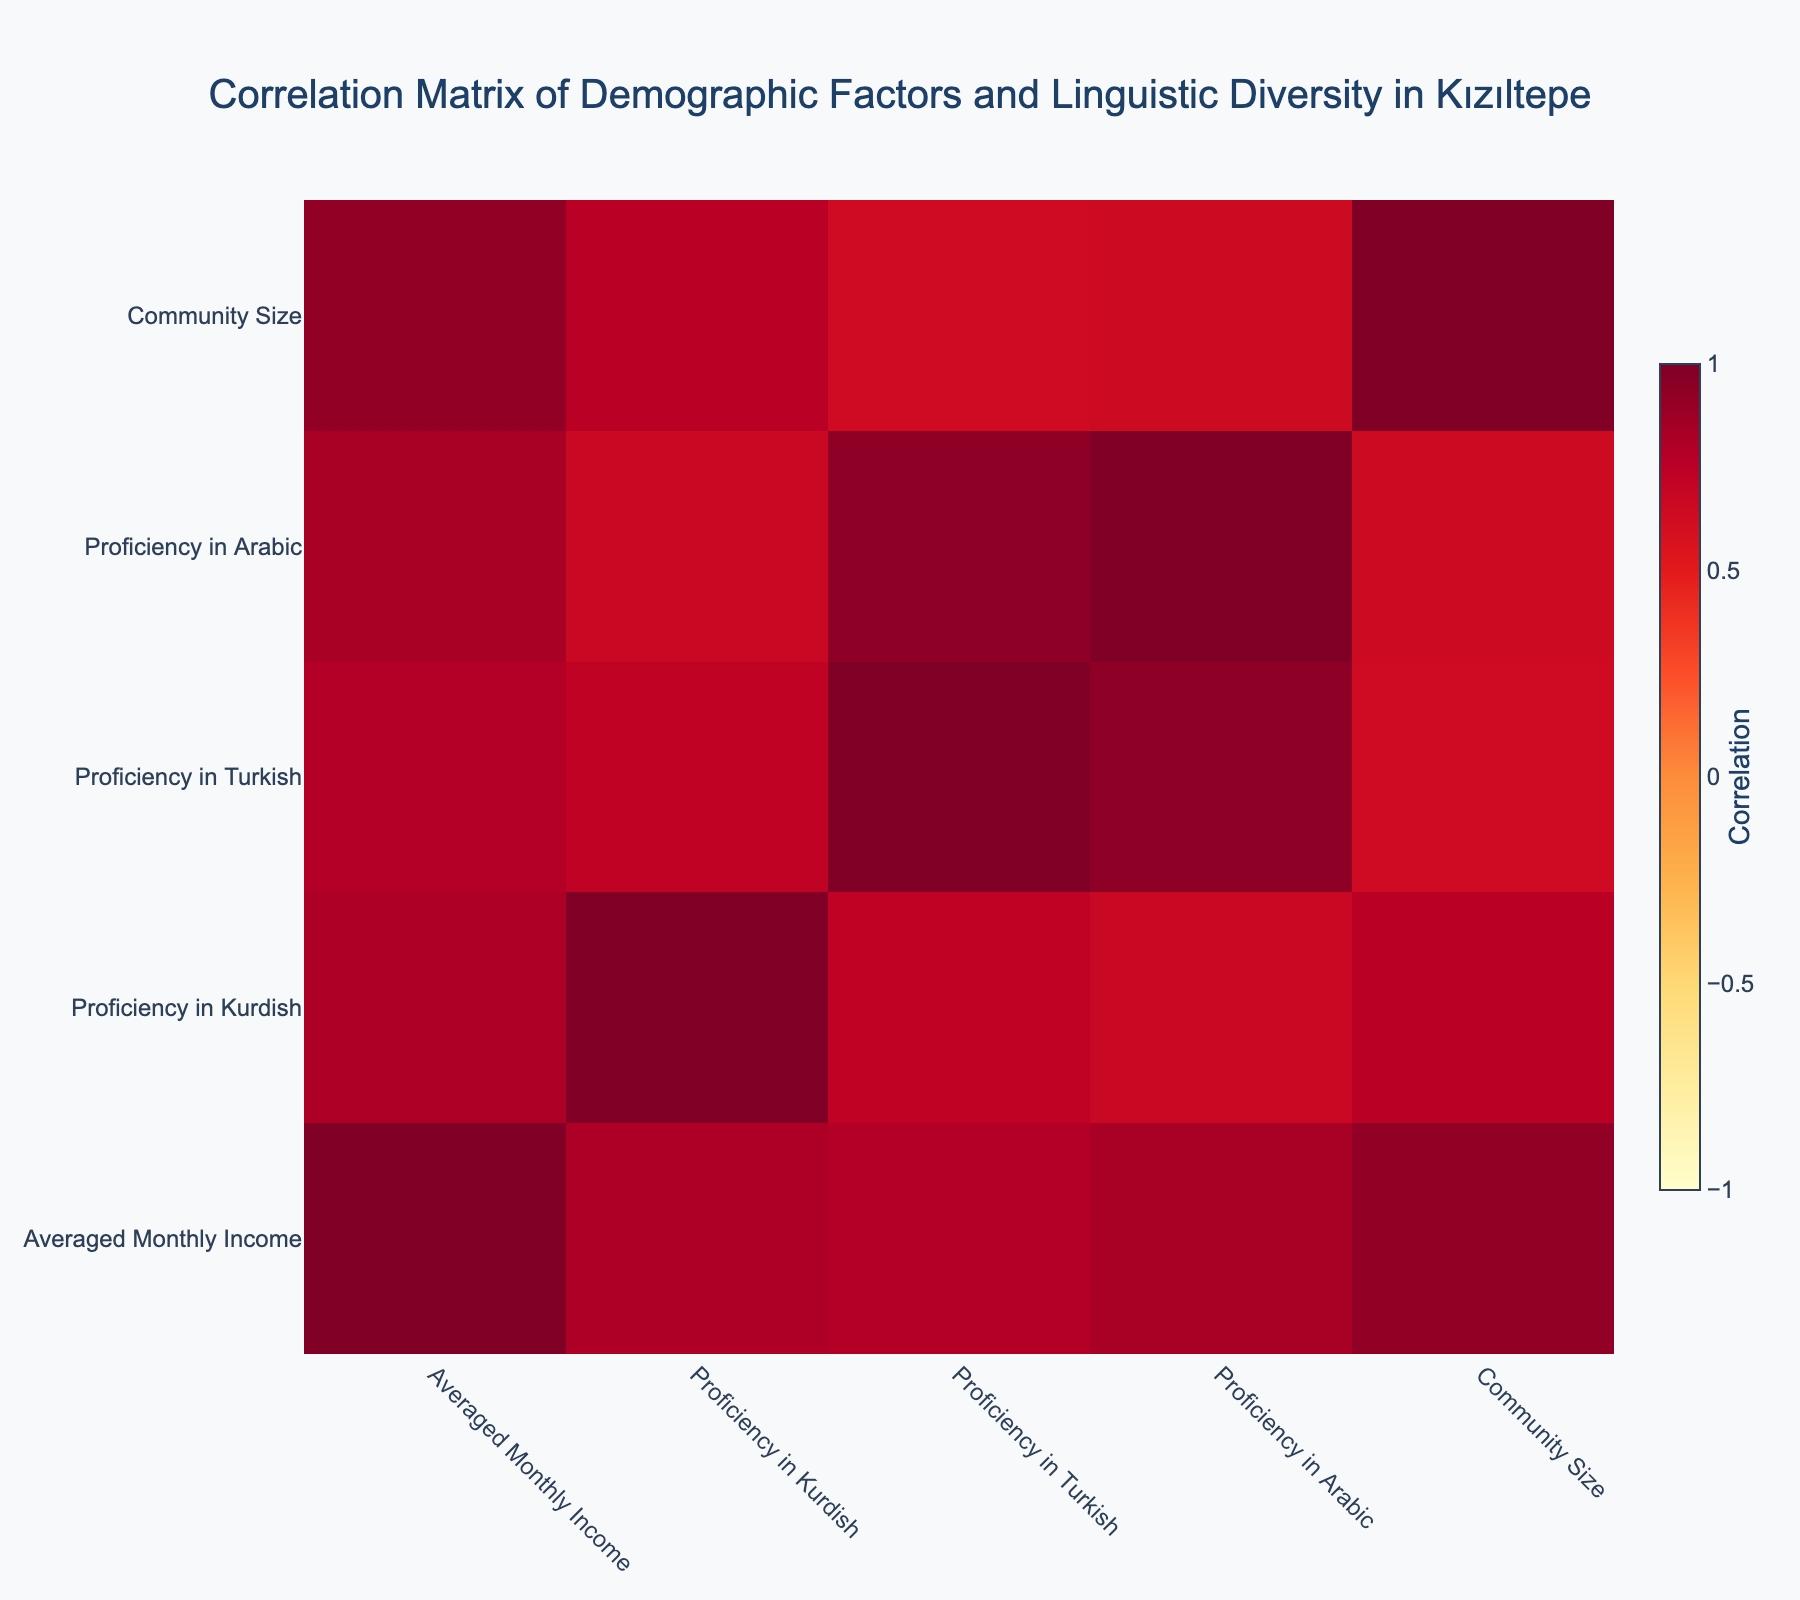What is the correlation between proficiency in Kurdish and averaged monthly income? To find the correlation between proficiency in Kurdish and averaged monthly income, we look at the correlation matrix in the table. The correlation value between these two variables will indicate how strongly they are related.
Answer: Correlation value How many individuals in the 35-44 age group are proficient in Arabic? We need to filter the rows to only include individuals in the 35-44 age group and then count how many of those individuals have a proficiency rating greater than 0 in Arabic. Based on the data, there are three individuals, two females and one male.
Answer: 3 Is it true that all individuals with a university degree have a higher proficiency in Turkish compared to those with a high school degree? To answer this, we examine the proficiency scores in Turkish for individuals with university and high school degrees. There are cases where university graduates score either equally or higher than high school graduates, but not all high school graduates have lower scores. Therefore, the statement is false.
Answer: False What is the average proficiency in Arabic for females across all age groups? To find the average proficiency in Arabic for females, we sum the Arabic proficiency values of all females and then divide by the number of females. The values are 3, 4, 2, and 1, which sum to 10. Since there are four females, the average is 10/4 = 2.5.
Answer: 2.5 Which gender has a higher average proficiency in Kurdish? We calculate the average proficiency in Kurdish for males and females separately. Based on the table, males have scores of 4, 5, 5, 3, 3, and 2 (for a total of 22 points) across different age groups. Females have scores of 5, 4, 4, 4, 3 (for a total of 20 points) in the same context. Male average is higher (22/6 = 3.67) compared to Female average (20/5 = 4.0), making Females slightly higher.
Answer: Female 